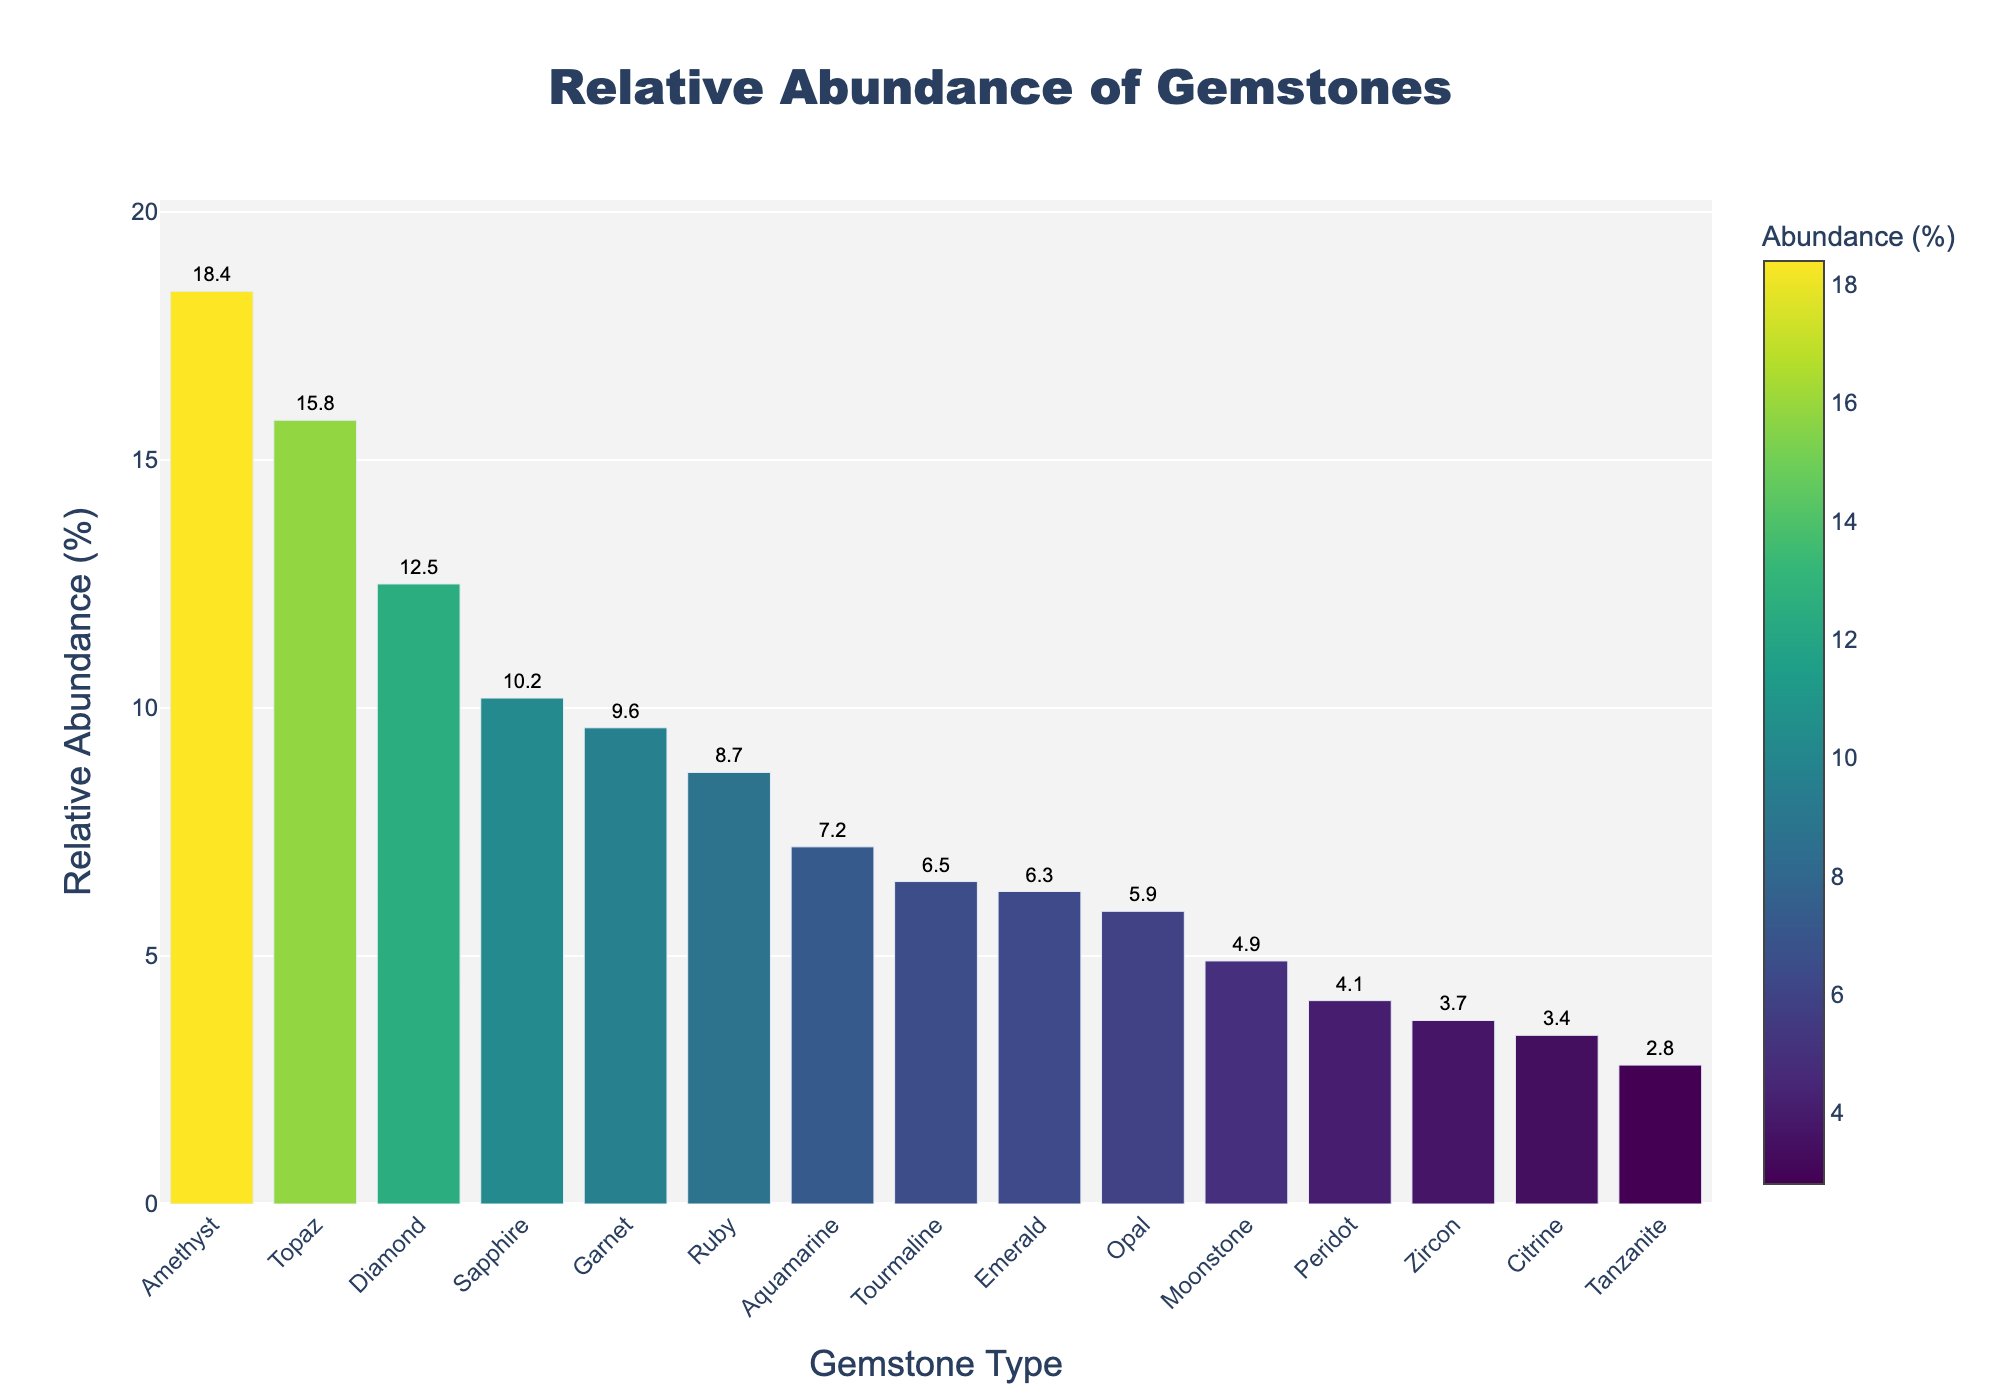What is the most abundant gemstone type? The tallest bar in the chart corresponds to the Amethyst, indicating it has the highest relative abundance.
Answer: Amethyst Which gemstone has a relative abundance greater than 10% but less than 15%? Identify the bars between 10% and 15%. Both Sapphire and Diamond fall within this range.
Answer: Sapphire, Diamond What is the combined relative abundance of Ruby and Emerald? Ruby has an abundance of 8.7%, and Emerald has 6.3%. Adding them together gives 8.7% + 6.3% = 15.0%.
Answer: 15.0% How does the relative abundance of Topaz compare to Amethyst? Amethyst has an abundance of 18.4%, and Topaz has 15.8%. Since 18.4% > 15.8%, Amethyst has a higher abundance.
Answer: Amethyst has a higher abundance Which gemstone has a greater relative abundance: Moonstone or Peridot? Moonstone has an abundance of 4.9%, and Peridot has 4.1%. Since 4.9% > 4.1%, Moonstone has a greater abundance.
Answer: Moonstone What is the sum of the abundances of the three least common gemstones? The least abundant gemstones are Tanzanite (2.8%), Zircon (3.7%), and Citrine (3.4%). Adding them together gives 2.8% + 3.7% + 3.4% = 9.9%.
Answer: 9.9% What is the difference in relative abundance between the most common and least common gemstones? The most common gemstone, Amethyst, has an abundance of 18.4%, and the least common, Tanzanite, has 2.8%. The difference is 18.4% - 2.8% = 15.6%.
Answer: 15.6% Which gemstone is closest in abundance to Aquamarine? Aquamarine has an abundance of 7.2%. The closest neighboring abundances are Ruby with 8.7% and Tourmaline with 6.5%. Tourmaline is 0.7% away, closer than Ruby.
Answer: Tourmaline How many gemstones have a relative abundance higher than 5%? Count the bars above the 5% threshold. These are Diamond, Ruby, Sapphire, Topaz, Amethyst, Garnet, Aquamarine, Tourmaline, and Moonstone. There are 9 gemstones.
Answer: 9 What color represents the gemstone with the second highest relative abundance? The second highest abundance after Amethyst (18.4%) is Topaz (15.8%), represented by the second tallest bar. Topaz is colored in a shade of green based on the Viridis palette.
Answer: Green 